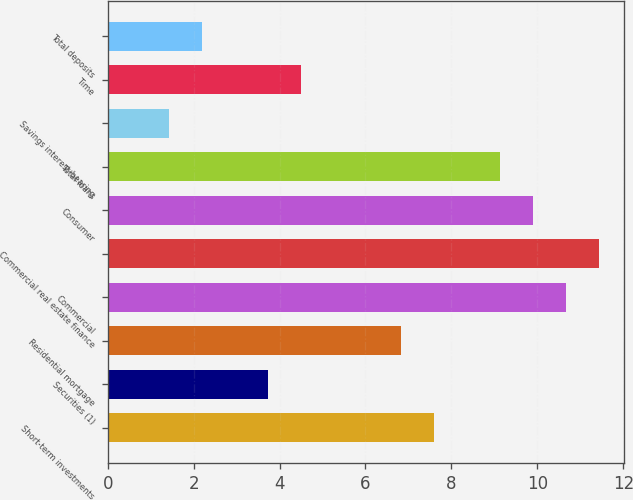<chart> <loc_0><loc_0><loc_500><loc_500><bar_chart><fcel>Short-term investments<fcel>Securities (1)<fcel>Residential mortgage<fcel>Commercial<fcel>Commercial real estate finance<fcel>Consumer<fcel>Total loans<fcel>Savings interest-bearing<fcel>Time<fcel>Total deposits<nl><fcel>7.59<fcel>3.74<fcel>6.82<fcel>10.67<fcel>11.44<fcel>9.9<fcel>9.13<fcel>1.42<fcel>4.51<fcel>2.19<nl></chart> 